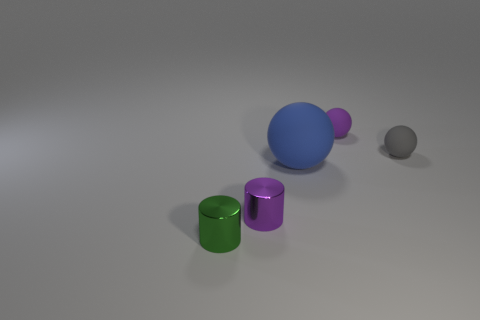Add 1 small green things. How many objects exist? 6 Subtract all cylinders. How many objects are left? 3 Subtract 1 gray spheres. How many objects are left? 4 Subtract all tiny purple matte balls. Subtract all tiny rubber things. How many objects are left? 2 Add 1 purple things. How many purple things are left? 3 Add 4 tiny brown matte blocks. How many tiny brown matte blocks exist? 4 